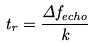<formula> <loc_0><loc_0><loc_500><loc_500>t _ { r } = \frac { \Delta f _ { e c h o } } { k }</formula> 